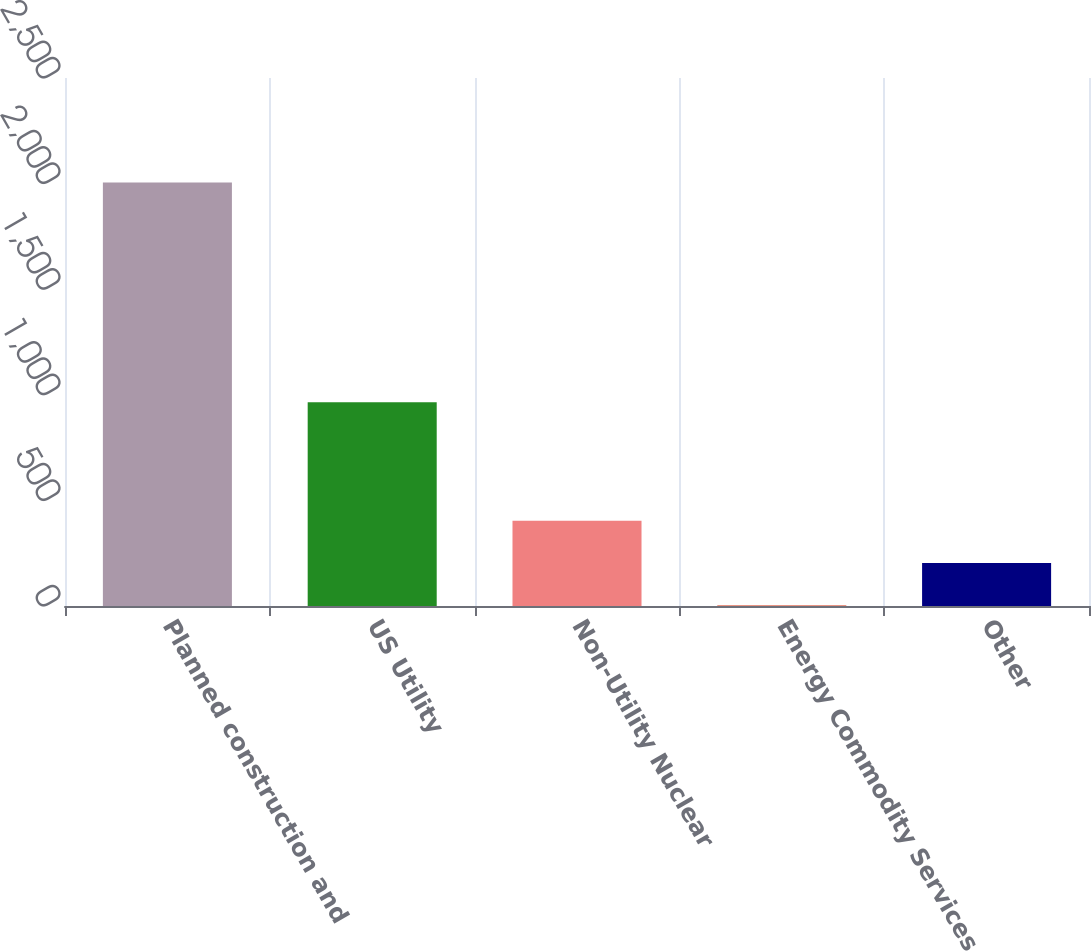<chart> <loc_0><loc_0><loc_500><loc_500><bar_chart><fcel>Planned construction and<fcel>US Utility<fcel>Non-Utility Nuclear<fcel>Energy Commodity Services<fcel>Other<nl><fcel>2005<fcel>965<fcel>403.4<fcel>3<fcel>203.2<nl></chart> 